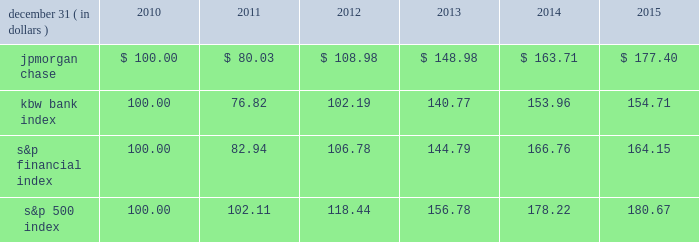Jpmorgan chase & co./2015 annual report 67 five-year stock performance the table and graph compare the five-year cumulative total return for jpmorgan chase & co .
( 201cjpmorgan chase 201d or the 201cfirm 201d ) common stock with the cumulative return of the s&p 500 index , the kbw bank index and the s&p financial index .
The s&p 500 index is a commonly referenced united states of america ( 201cu.s . 201d ) equity benchmark consisting of leading companies from different economic sectors .
The kbw bank index seeks to reflect the performance of banks and thrifts that are publicly traded in the u.s .
And is composed of 24 leading national money center and regional banks and thrifts .
The s&p financial index is an index of 87 financial companies , all of which are components of the s&p 500 .
The firm is a component of all three industry indices .
The table and graph assume simultaneous investments of $ 100 on december 31 , 2010 , in jpmorgan chase common stock and in each of the above indices .
The comparison assumes that all dividends are reinvested .
December 31 , ( in dollars ) 2010 2011 2012 2013 2014 2015 .
December 31 , ( in dollars ) .
Did jpmorgan chase outperform the kbw bank index? 
Computations: (177.40 > 154.71)
Answer: yes. 